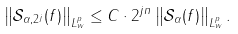Convert formula to latex. <formula><loc_0><loc_0><loc_500><loc_500>\left \| \mathcal { S } _ { \alpha , 2 ^ { j } } ( f ) \right \| _ { L ^ { p } _ { w } } \leq C \cdot 2 ^ { j n } \left \| \mathcal { S } _ { \alpha } ( f ) \right \| _ { L ^ { p } _ { w } } .</formula> 